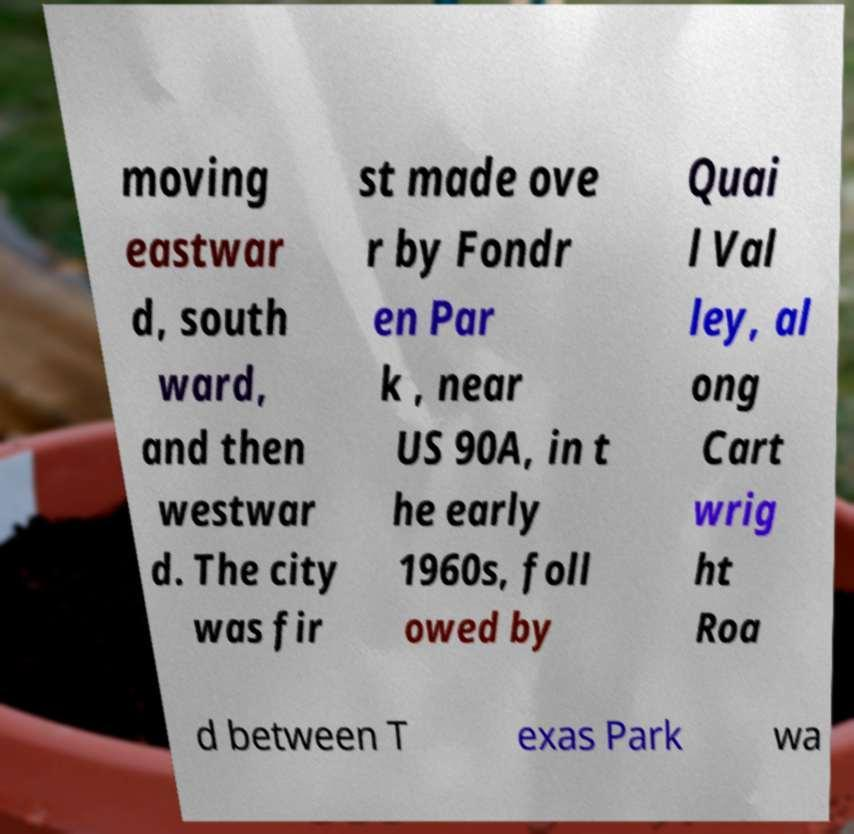For documentation purposes, I need the text within this image transcribed. Could you provide that? moving eastwar d, south ward, and then westwar d. The city was fir st made ove r by Fondr en Par k , near US 90A, in t he early 1960s, foll owed by Quai l Val ley, al ong Cart wrig ht Roa d between T exas Park wa 